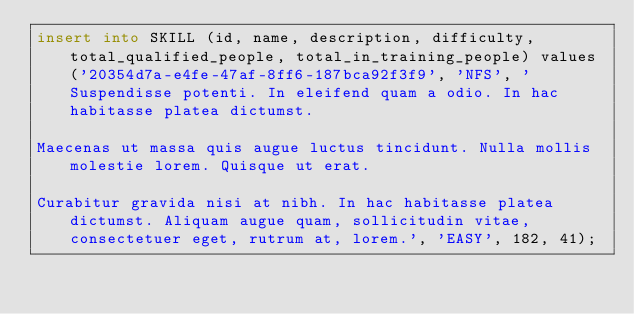<code> <loc_0><loc_0><loc_500><loc_500><_SQL_>insert into SKILL (id, name, description, difficulty, total_qualified_people, total_in_training_people) values ('20354d7a-e4fe-47af-8ff6-187bca92f3f9', 'NFS', 'Suspendisse potenti. In eleifend quam a odio. In hac habitasse platea dictumst.

Maecenas ut massa quis augue luctus tincidunt. Nulla mollis molestie lorem. Quisque ut erat.

Curabitur gravida nisi at nibh. In hac habitasse platea dictumst. Aliquam augue quam, sollicitudin vitae, consectetuer eget, rutrum at, lorem.', 'EASY', 182, 41);</code> 